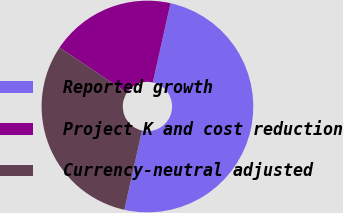Convert chart to OTSL. <chart><loc_0><loc_0><loc_500><loc_500><pie_chart><fcel>Reported growth<fcel>Project K and cost reduction<fcel>Currency-neutral adjusted<nl><fcel>50.0%<fcel>19.11%<fcel>30.89%<nl></chart> 